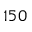<formula> <loc_0><loc_0><loc_500><loc_500>1 5 0</formula> 